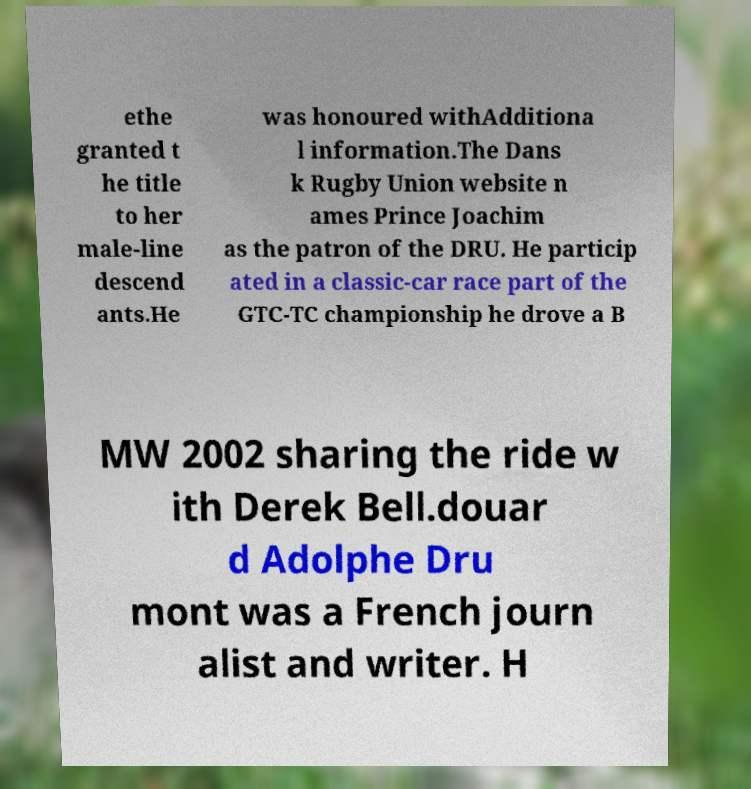For documentation purposes, I need the text within this image transcribed. Could you provide that? ethe granted t he title to her male-line descend ants.He was honoured withAdditiona l information.The Dans k Rugby Union website n ames Prince Joachim as the patron of the DRU. He particip ated in a classic-car race part of the GTC-TC championship he drove a B MW 2002 sharing the ride w ith Derek Bell.douar d Adolphe Dru mont was a French journ alist and writer. H 